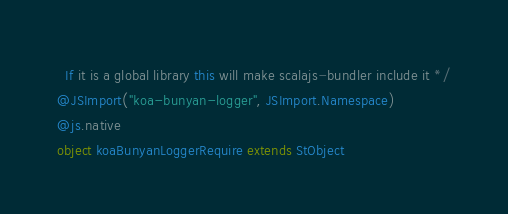<code> <loc_0><loc_0><loc_500><loc_500><_Scala_>  If it is a global library this will make scalajs-bundler include it */
@JSImport("koa-bunyan-logger", JSImport.Namespace)
@js.native
object koaBunyanLoggerRequire extends StObject
</code> 